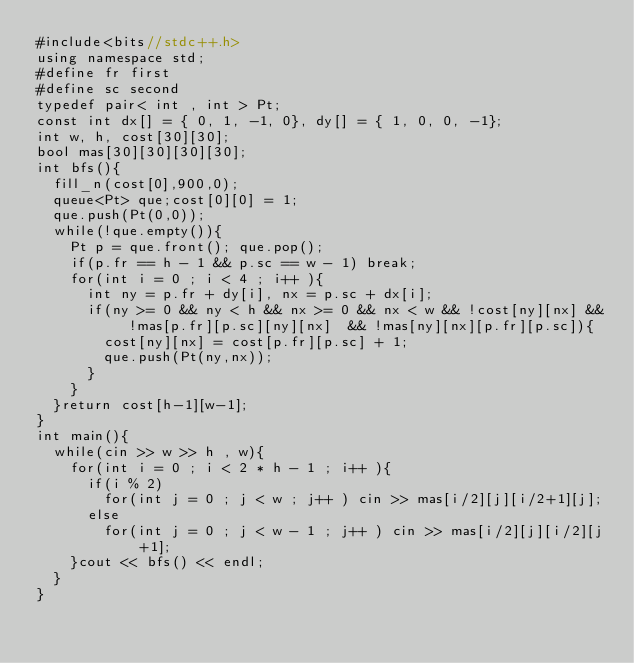<code> <loc_0><loc_0><loc_500><loc_500><_C++_>#include<bits//stdc++.h>
using namespace std;
#define fr first
#define sc second
typedef pair< int , int > Pt;
const int dx[] = { 0, 1, -1, 0}, dy[] = { 1, 0, 0, -1};
int w, h, cost[30][30];
bool mas[30][30][30][30];
int bfs(){
  fill_n(cost[0],900,0);
  queue<Pt> que;cost[0][0] = 1;
  que.push(Pt(0,0));
  while(!que.empty()){
    Pt p = que.front(); que.pop();
    if(p.fr == h - 1 && p.sc == w - 1) break;
    for(int i = 0 ; i < 4 ; i++ ){
      int ny = p.fr + dy[i], nx = p.sc + dx[i];
      if(ny >= 0 && ny < h && nx >= 0 && nx < w && !cost[ny][nx] && !mas[p.fr][p.sc][ny][nx]  && !mas[ny][nx][p.fr][p.sc]){
        cost[ny][nx] = cost[p.fr][p.sc] + 1;
        que.push(Pt(ny,nx));
      }
    }
  }return cost[h-1][w-1];
}
int main(){
  while(cin >> w >> h , w){
    for(int i = 0 ; i < 2 * h - 1 ; i++ ){
      if(i % 2)
        for(int j = 0 ; j < w ; j++ ) cin >> mas[i/2][j][i/2+1][j];
      else
        for(int j = 0 ; j < w - 1 ; j++ ) cin >> mas[i/2][j][i/2][j+1];
    }cout << bfs() << endl;
  }
}
</code> 